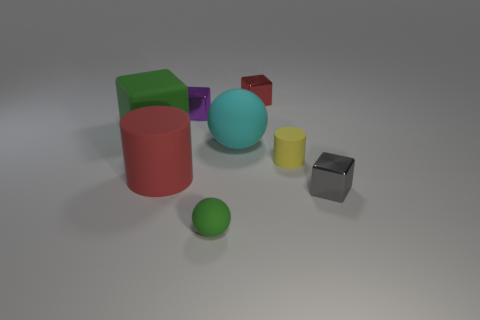Add 2 yellow objects. How many objects exist? 10 Subtract all spheres. How many objects are left? 6 Add 6 yellow matte cylinders. How many yellow matte cylinders exist? 7 Subtract 1 red blocks. How many objects are left? 7 Subtract all tiny gray shiny blocks. Subtract all red matte cylinders. How many objects are left? 6 Add 6 tiny yellow cylinders. How many tiny yellow cylinders are left? 7 